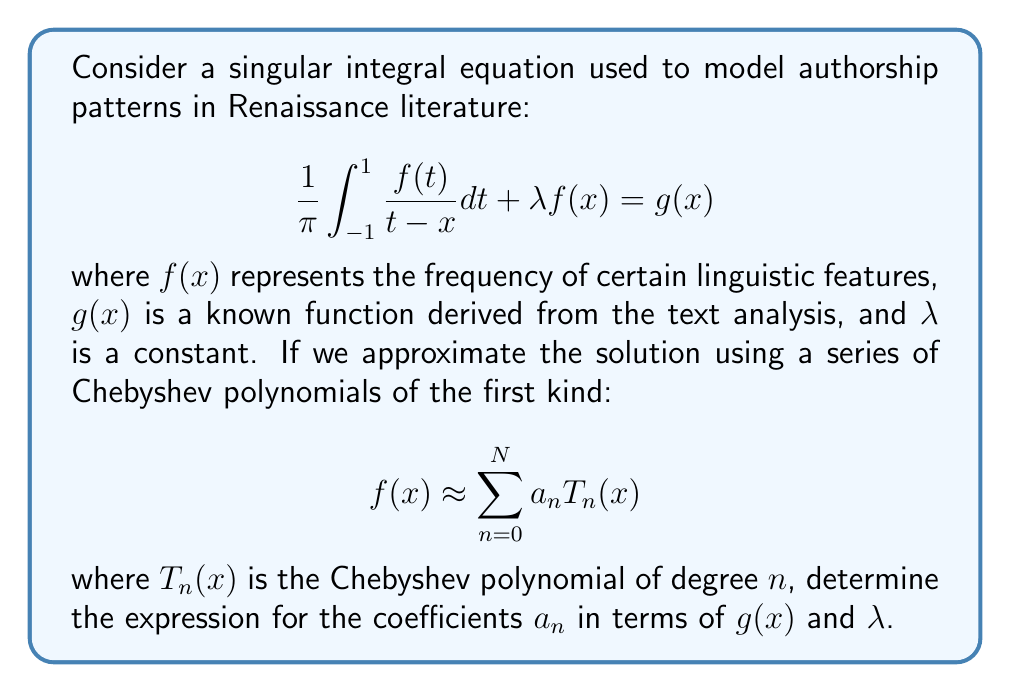Could you help me with this problem? To solve this problem, we'll follow these steps:

1) First, recall that Chebyshev polynomials of the first kind satisfy the following property:

   $$\frac{1}{\pi} \int_{-1}^{1} \frac{T_n(t)}{t-x} dt = -Q_{n-1}(x)$$

   where $Q_n(x)$ is the Chebyshev function of the second kind.

2) Substitute the approximation into the original equation:

   $$\frac{1}{\pi} \int_{-1}^{1} \frac{\sum_{n=0}^{N} a_n T_n(t)}{t-x} dt + \lambda \sum_{n=0}^{N} a_n T_n(x) = g(x)$$

3) Using the property from step 1, we can simplify:

   $$-\sum_{n=0}^{N} a_n Q_{n-1}(x) + \lambda \sum_{n=0}^{N} a_n T_n(x) = g(x)$$

4) Now, we use the relationship between Chebyshev polynomials and functions:

   $$Q_{n-1}(x) = U_{n-1}(x)$$
   $$T_n(x) = U_n(x) - xU_{n-1}(x)$$

   where $U_n(x)$ is the Chebyshev polynomial of the second kind.

5) Substituting these relationships:

   $$-\sum_{n=0}^{N} a_n U_{n-1}(x) + \lambda \sum_{n=0}^{N} a_n [U_n(x) - xU_{n-1}(x)] = g(x)$$

6) Rearranging terms:

   $$\sum_{n=0}^{N} a_n [\lambda U_n(x) - (1 + \lambda x)U_{n-1}(x)] = g(x)$$

7) Now, we can use the orthogonality property of Chebyshev polynomials:

   $$\int_{-1}^{1} \frac{U_m(x)U_n(x)}{\sqrt{1-x^2}} dx = \frac{\pi}{2} \delta_{mn}$$

   where $\delta_{mn}$ is the Kronecker delta.

8) Multiply both sides by $U_m(x)/\sqrt{1-x^2}$ and integrate from -1 to 1:

   $$\sum_{n=0}^{N} a_n [\lambda \frac{\pi}{2}\delta_{mn} - (1 + \lambda x)\frac{\pi}{2}\delta_{m,n-1}] = \int_{-1}^{1} \frac{U_m(x)g(x)}{\sqrt{1-x^2}} dx$$

9) This gives us a system of linear equations for the coefficients $a_n$. The solution can be written as:

   $$a_n = \frac{2}{\pi\lambda} \int_{-1}^{1} \frac{U_n(x)g(x)}{\sqrt{1-x^2}} dx - \frac{1 + \lambda x}{\lambda} a_{n+1}$$

   for $n = N-1, N-2, ..., 0$, with $a_N = \frac{2}{\pi\lambda} \int_{-1}^{1} \frac{U_N(x)g(x)}{\sqrt{1-x^2}} dx$.
Answer: $a_n = \frac{2}{\pi\lambda} \int_{-1}^{1} \frac{U_n(x)g(x)}{\sqrt{1-x^2}} dx - \frac{1 + \lambda x}{\lambda} a_{n+1}$ 